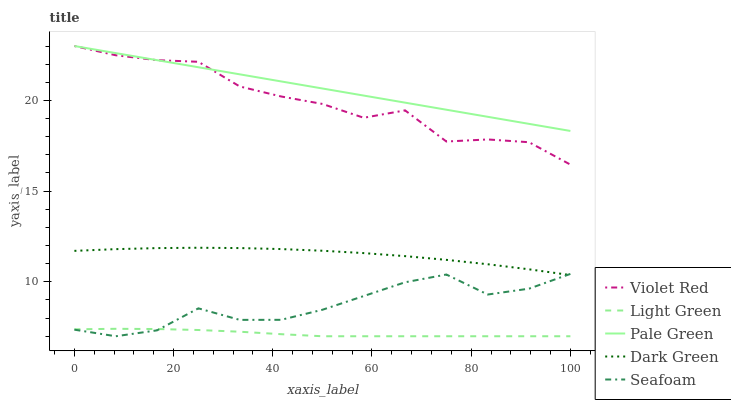Does Light Green have the minimum area under the curve?
Answer yes or no. Yes. Does Pale Green have the maximum area under the curve?
Answer yes or no. Yes. Does Seafoam have the minimum area under the curve?
Answer yes or no. No. Does Seafoam have the maximum area under the curve?
Answer yes or no. No. Is Pale Green the smoothest?
Answer yes or no. Yes. Is Violet Red the roughest?
Answer yes or no. Yes. Is Seafoam the smoothest?
Answer yes or no. No. Is Seafoam the roughest?
Answer yes or no. No. Does Seafoam have the lowest value?
Answer yes or no. Yes. Does Pale Green have the lowest value?
Answer yes or no. No. Does Pale Green have the highest value?
Answer yes or no. Yes. Does Seafoam have the highest value?
Answer yes or no. No. Is Seafoam less than Pale Green?
Answer yes or no. Yes. Is Pale Green greater than Light Green?
Answer yes or no. Yes. Does Pale Green intersect Violet Red?
Answer yes or no. Yes. Is Pale Green less than Violet Red?
Answer yes or no. No. Is Pale Green greater than Violet Red?
Answer yes or no. No. Does Seafoam intersect Pale Green?
Answer yes or no. No. 